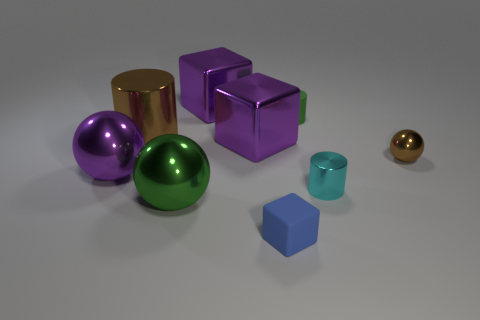Subtract all spheres. How many objects are left? 6 Add 6 large spheres. How many large spheres exist? 8 Subtract 1 purple blocks. How many objects are left? 8 Subtract all tiny blocks. Subtract all green spheres. How many objects are left? 7 Add 3 tiny things. How many tiny things are left? 7 